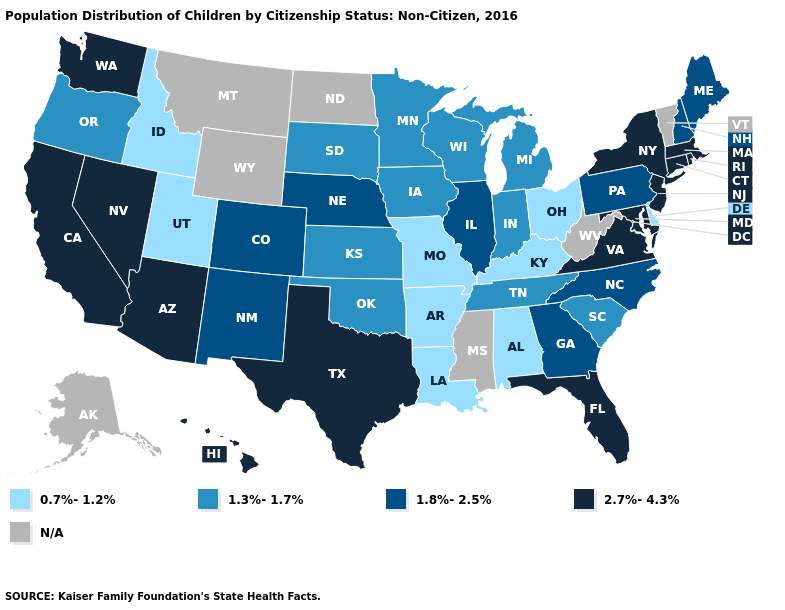What is the value of Massachusetts?
Short answer required. 2.7%-4.3%. Does the map have missing data?
Keep it brief. Yes. Does the first symbol in the legend represent the smallest category?
Short answer required. Yes. Among the states that border Arkansas , does Louisiana have the highest value?
Answer briefly. No. Name the states that have a value in the range N/A?
Keep it brief. Alaska, Mississippi, Montana, North Dakota, Vermont, West Virginia, Wyoming. Which states have the highest value in the USA?
Answer briefly. Arizona, California, Connecticut, Florida, Hawaii, Maryland, Massachusetts, Nevada, New Jersey, New York, Rhode Island, Texas, Virginia, Washington. What is the highest value in the USA?
Quick response, please. 2.7%-4.3%. Which states hav the highest value in the West?
Quick response, please. Arizona, California, Hawaii, Nevada, Washington. Among the states that border Arkansas , does Louisiana have the highest value?
Be succinct. No. Does the map have missing data?
Answer briefly. Yes. What is the highest value in the USA?
Quick response, please. 2.7%-4.3%. What is the lowest value in states that border Illinois?
Quick response, please. 0.7%-1.2%. Does Illinois have the highest value in the MidWest?
Quick response, please. Yes. Does Arkansas have the lowest value in the USA?
Concise answer only. Yes. Does New Jersey have the highest value in the Northeast?
Keep it brief. Yes. 